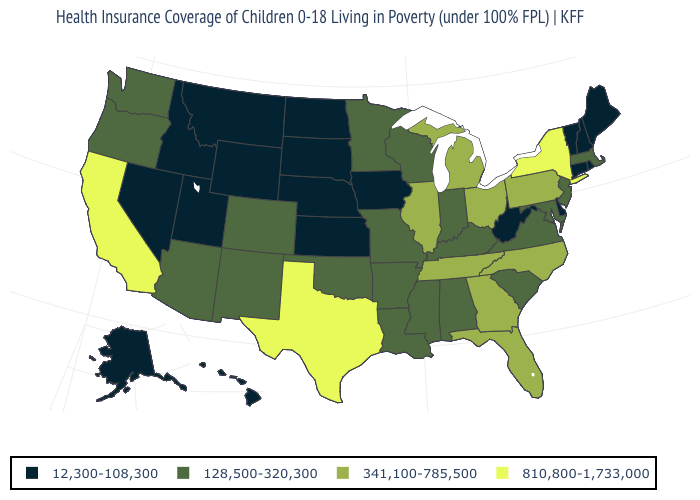What is the value of Maryland?
Write a very short answer. 128,500-320,300. What is the value of Oklahoma?
Concise answer only. 128,500-320,300. What is the value of New York?
Keep it brief. 810,800-1,733,000. Among the states that border New York , does Massachusetts have the lowest value?
Answer briefly. No. Does the first symbol in the legend represent the smallest category?
Concise answer only. Yes. Which states hav the highest value in the Northeast?
Short answer required. New York. What is the highest value in the MidWest ?
Answer briefly. 341,100-785,500. What is the lowest value in states that border Michigan?
Quick response, please. 128,500-320,300. Does Texas have a higher value than Ohio?
Be succinct. Yes. What is the value of Arizona?
Concise answer only. 128,500-320,300. Among the states that border New York , which have the highest value?
Concise answer only. Pennsylvania. Does New Hampshire have a higher value than California?
Give a very brief answer. No. Does Wyoming have the highest value in the USA?
Answer briefly. No. Name the states that have a value in the range 810,800-1,733,000?
Write a very short answer. California, New York, Texas. Which states have the lowest value in the USA?
Short answer required. Alaska, Connecticut, Delaware, Hawaii, Idaho, Iowa, Kansas, Maine, Montana, Nebraska, Nevada, New Hampshire, North Dakota, Rhode Island, South Dakota, Utah, Vermont, West Virginia, Wyoming. 